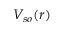Convert formula to latex. <formula><loc_0><loc_0><loc_500><loc_500>V _ { s o } ( r )</formula> 